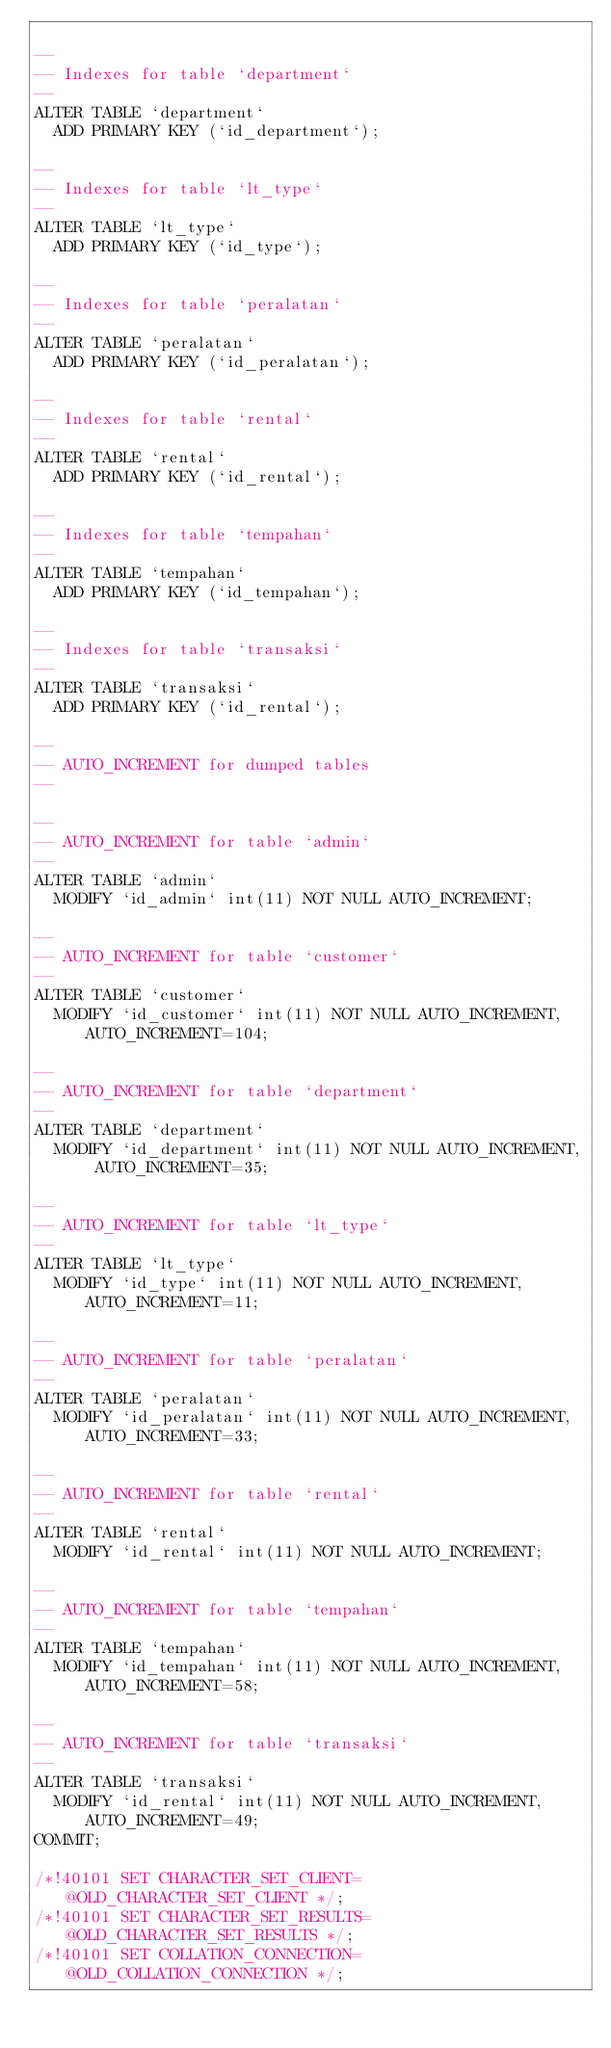Convert code to text. <code><loc_0><loc_0><loc_500><loc_500><_SQL_>
--
-- Indexes for table `department`
--
ALTER TABLE `department`
  ADD PRIMARY KEY (`id_department`);

--
-- Indexes for table `lt_type`
--
ALTER TABLE `lt_type`
  ADD PRIMARY KEY (`id_type`);

--
-- Indexes for table `peralatan`
--
ALTER TABLE `peralatan`
  ADD PRIMARY KEY (`id_peralatan`);

--
-- Indexes for table `rental`
--
ALTER TABLE `rental`
  ADD PRIMARY KEY (`id_rental`);

--
-- Indexes for table `tempahan`
--
ALTER TABLE `tempahan`
  ADD PRIMARY KEY (`id_tempahan`);

--
-- Indexes for table `transaksi`
--
ALTER TABLE `transaksi`
  ADD PRIMARY KEY (`id_rental`);

--
-- AUTO_INCREMENT for dumped tables
--

--
-- AUTO_INCREMENT for table `admin`
--
ALTER TABLE `admin`
  MODIFY `id_admin` int(11) NOT NULL AUTO_INCREMENT;

--
-- AUTO_INCREMENT for table `customer`
--
ALTER TABLE `customer`
  MODIFY `id_customer` int(11) NOT NULL AUTO_INCREMENT, AUTO_INCREMENT=104;

--
-- AUTO_INCREMENT for table `department`
--
ALTER TABLE `department`
  MODIFY `id_department` int(11) NOT NULL AUTO_INCREMENT, AUTO_INCREMENT=35;

--
-- AUTO_INCREMENT for table `lt_type`
--
ALTER TABLE `lt_type`
  MODIFY `id_type` int(11) NOT NULL AUTO_INCREMENT, AUTO_INCREMENT=11;

--
-- AUTO_INCREMENT for table `peralatan`
--
ALTER TABLE `peralatan`
  MODIFY `id_peralatan` int(11) NOT NULL AUTO_INCREMENT, AUTO_INCREMENT=33;

--
-- AUTO_INCREMENT for table `rental`
--
ALTER TABLE `rental`
  MODIFY `id_rental` int(11) NOT NULL AUTO_INCREMENT;

--
-- AUTO_INCREMENT for table `tempahan`
--
ALTER TABLE `tempahan`
  MODIFY `id_tempahan` int(11) NOT NULL AUTO_INCREMENT, AUTO_INCREMENT=58;

--
-- AUTO_INCREMENT for table `transaksi`
--
ALTER TABLE `transaksi`
  MODIFY `id_rental` int(11) NOT NULL AUTO_INCREMENT, AUTO_INCREMENT=49;
COMMIT;

/*!40101 SET CHARACTER_SET_CLIENT=@OLD_CHARACTER_SET_CLIENT */;
/*!40101 SET CHARACTER_SET_RESULTS=@OLD_CHARACTER_SET_RESULTS */;
/*!40101 SET COLLATION_CONNECTION=@OLD_COLLATION_CONNECTION */;
</code> 